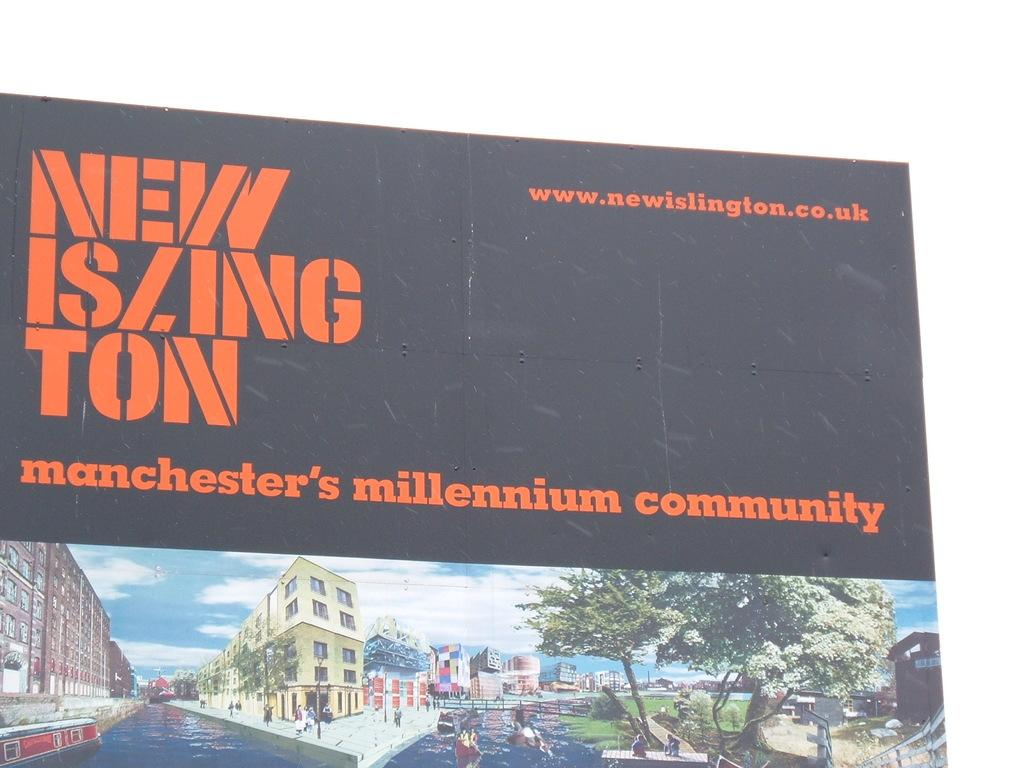<image>
Create a compact narrative representing the image presented. A black sign advertises Manchester's millenium community in orange text. 